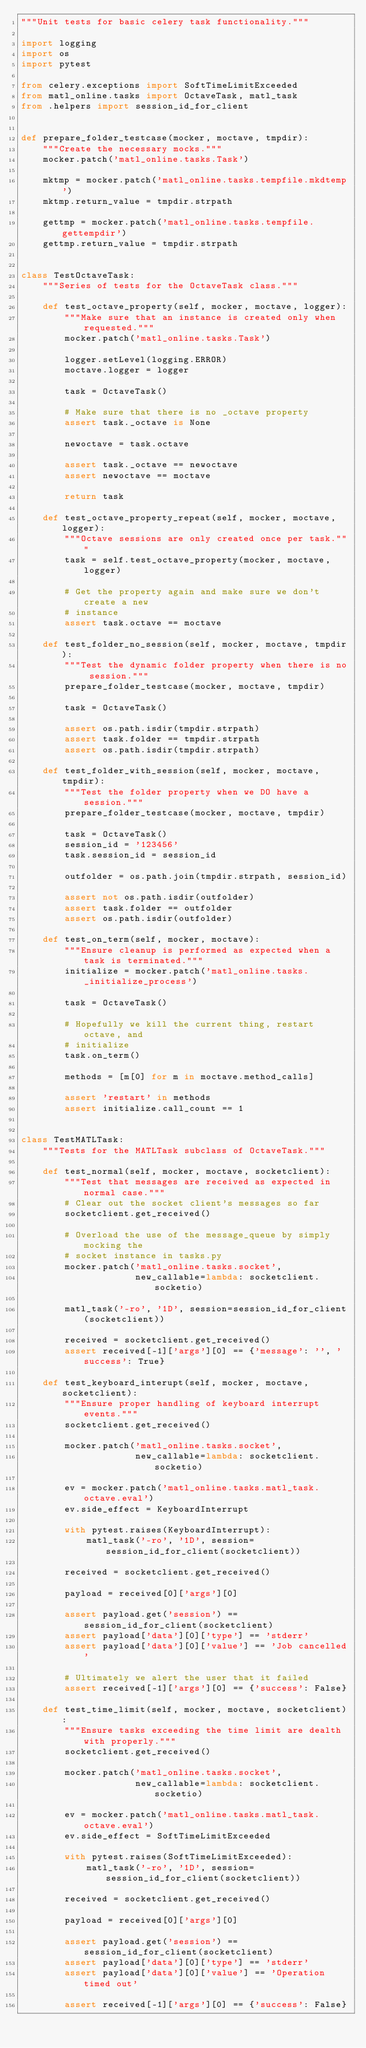Convert code to text. <code><loc_0><loc_0><loc_500><loc_500><_Python_>"""Unit tests for basic celery task functionality."""

import logging
import os
import pytest

from celery.exceptions import SoftTimeLimitExceeded
from matl_online.tasks import OctaveTask, matl_task
from .helpers import session_id_for_client


def prepare_folder_testcase(mocker, moctave, tmpdir):
    """Create the necessary mocks."""
    mocker.patch('matl_online.tasks.Task')

    mktmp = mocker.patch('matl_online.tasks.tempfile.mkdtemp')
    mktmp.return_value = tmpdir.strpath

    gettmp = mocker.patch('matl_online.tasks.tempfile.gettempdir')
    gettmp.return_value = tmpdir.strpath


class TestOctaveTask:
    """Series of tests for the OctaveTask class."""

    def test_octave_property(self, mocker, moctave, logger):
        """Make sure that an instance is created only when requested."""
        mocker.patch('matl_online.tasks.Task')

        logger.setLevel(logging.ERROR)
        moctave.logger = logger

        task = OctaveTask()

        # Make sure that there is no _octave property
        assert task._octave is None

        newoctave = task.octave

        assert task._octave == newoctave
        assert newoctave == moctave

        return task

    def test_octave_property_repeat(self, mocker, moctave, logger):
        """Octave sessions are only created once per task."""
        task = self.test_octave_property(mocker, moctave, logger)

        # Get the property again and make sure we don't create a new
        # instance
        assert task.octave == moctave

    def test_folder_no_session(self, mocker, moctave, tmpdir):
        """Test the dynamic folder property when there is no session."""
        prepare_folder_testcase(mocker, moctave, tmpdir)

        task = OctaveTask()

        assert os.path.isdir(tmpdir.strpath)
        assert task.folder == tmpdir.strpath
        assert os.path.isdir(tmpdir.strpath)

    def test_folder_with_session(self, mocker, moctave, tmpdir):
        """Test the folder property when we DO have a session."""
        prepare_folder_testcase(mocker, moctave, tmpdir)

        task = OctaveTask()
        session_id = '123456'
        task.session_id = session_id

        outfolder = os.path.join(tmpdir.strpath, session_id)

        assert not os.path.isdir(outfolder)
        assert task.folder == outfolder
        assert os.path.isdir(outfolder)

    def test_on_term(self, mocker, moctave):
        """Ensure cleanup is performed as expected when a task is terminated."""
        initialize = mocker.patch('matl_online.tasks._initialize_process')

        task = OctaveTask()

        # Hopefully we kill the current thing, restart octave, and
        # initialize
        task.on_term()

        methods = [m[0] for m in moctave.method_calls]

        assert 'restart' in methods
        assert initialize.call_count == 1


class TestMATLTask:
    """Tests for the MATLTask subclass of OctaveTask."""

    def test_normal(self, mocker, moctave, socketclient):
        """Test that messages are received as expected in normal case."""
        # Clear out the socket client's messages so far
        socketclient.get_received()

        # Overload the use of the message_queue by simply mocking the
        # socket instance in tasks.py
        mocker.patch('matl_online.tasks.socket',
                     new_callable=lambda: socketclient.socketio)

        matl_task('-ro', '1D', session=session_id_for_client(socketclient))

        received = socketclient.get_received()
        assert received[-1]['args'][0] == {'message': '', 'success': True}

    def test_keyboard_interupt(self, mocker, moctave, socketclient):
        """Ensure proper handling of keyboard interrupt events."""
        socketclient.get_received()

        mocker.patch('matl_online.tasks.socket',
                     new_callable=lambda: socketclient.socketio)

        ev = mocker.patch('matl_online.tasks.matl_task.octave.eval')
        ev.side_effect = KeyboardInterrupt

        with pytest.raises(KeyboardInterrupt):
            matl_task('-ro', '1D', session=session_id_for_client(socketclient))

        received = socketclient.get_received()

        payload = received[0]['args'][0]

        assert payload.get('session') == session_id_for_client(socketclient)
        assert payload['data'][0]['type'] == 'stderr'
        assert payload['data'][0]['value'] == 'Job cancelled'

        # Ultimately we alert the user that it failed
        assert received[-1]['args'][0] == {'success': False}

    def test_time_limit(self, mocker, moctave, socketclient):
        """Ensure tasks exceeding the time limit are dealth with properly."""
        socketclient.get_received()

        mocker.patch('matl_online.tasks.socket',
                     new_callable=lambda: socketclient.socketio)

        ev = mocker.patch('matl_online.tasks.matl_task.octave.eval')
        ev.side_effect = SoftTimeLimitExceeded

        with pytest.raises(SoftTimeLimitExceeded):
            matl_task('-ro', '1D', session=session_id_for_client(socketclient))

        received = socketclient.get_received()

        payload = received[0]['args'][0]

        assert payload.get('session') == session_id_for_client(socketclient)
        assert payload['data'][0]['type'] == 'stderr'
        assert payload['data'][0]['value'] == 'Operation timed out'

        assert received[-1]['args'][0] == {'success': False}
</code> 